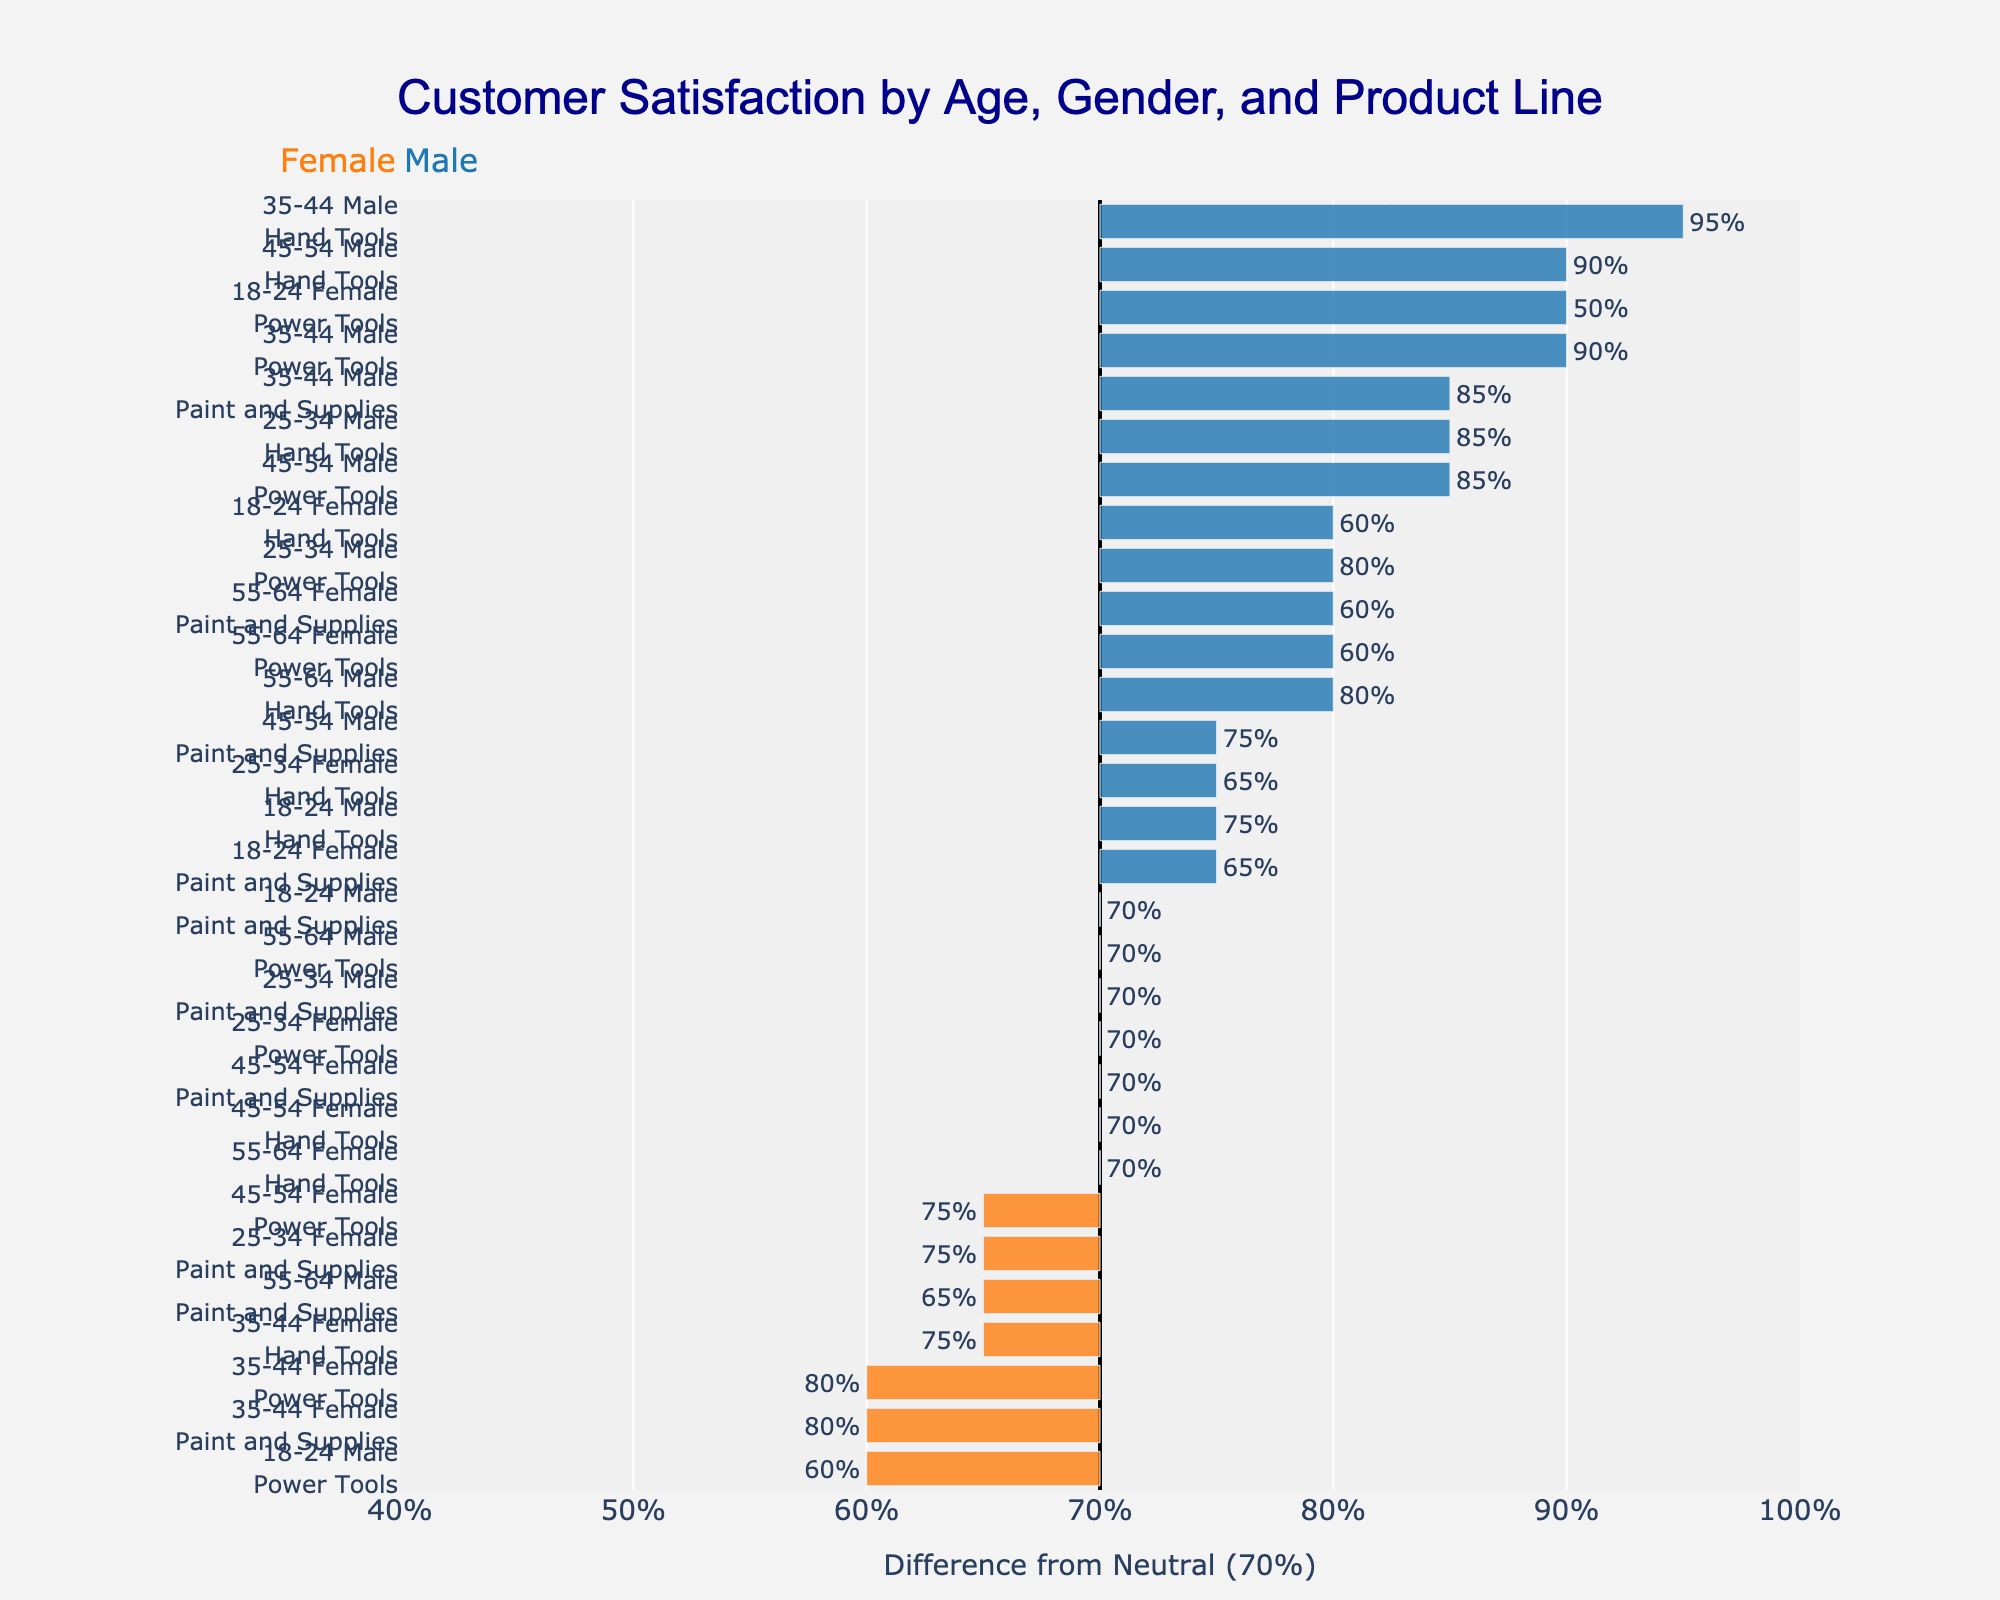Which age group has the highest satisfaction with Power Tools among males? Look at the different bars corresponding to males and Power Tools across age groups. The highest bar shows the satisfaction level, which is for the 35-44 age group with 90%.
Answer: 35-44 What's the difference in customer satisfaction for Hand Tools between males aged 25-34 and females aged 25-34? The satisfaction for males aged 25-34 is 85%, and for females aged 25-34 is 65%. The difference is 85% - 65% = 20%.
Answer: 20% Which product line do females aged 55-64 express the least satisfaction with, and what is the satisfaction level? Find the bars for females aged 55-64 for each product line. The smallest bar corresponds to Paint and Supplies with a satisfaction of 60%.
Answer: Paint and Supplies, 60% How does the average satisfaction for Power Tools compare between males and females aged 35-44? The satisfaction for males aged 35-44 is 90%, and for females aged 35-44 is 80%. The average for these is (90% + 80%) / 2 = 85%.
Answer: 85% Which gender shows overall higher satisfaction levels across all age groups for Paint and Supplies, and by how much? Compare the heights of bars for Paint and Supplies across different age groups for both genders. Summing up, males show higher satisfaction as their satisfaction levels are: 70%, 70%, 85%, 75%, 65% = 365%. For females, it is: 65%, 75%, 80%, 70%, 60% = 350%. The difference is 365% - 350% = 15%.
Answer: Males, 15% What is the lowest customer satisfaction value for any product line among females aged 45-54, and which product line does it correspond to? Look for the lowest satisfaction value among females aged 45-54. The lowest value is for Paint and Supplies with a satisfaction of 70%.
Answer: Paint and Supplies, 70% Is there any age group where the satisfaction level for Paint and Supplies is the same for both genders? If yes, state the age group and satisfaction level. Check the bars for Paint and Supplies across age groups and genders. The satisfaction level for Paint and Supplies is the same at 70% for both genders in the 25-34 age group.
Answer: 25-34, 70% Which product line has the highest average satisfaction rating among males aged 18-24? Calculate the average satisfaction for Power Tools, Hand Tools, and Paint and Supplies among males aged 18-24. The ratings are 60%, 75%, and 70%, respectively. The highest average is for Hand Tools: (75%)
Answer: Hand Tools 